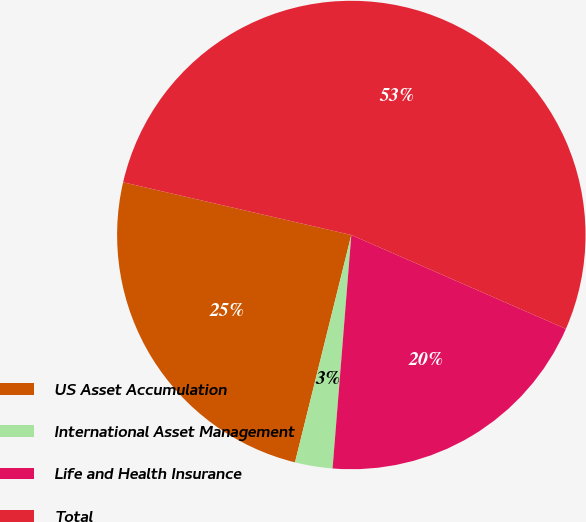Convert chart. <chart><loc_0><loc_0><loc_500><loc_500><pie_chart><fcel>US Asset Accumulation<fcel>International Asset Management<fcel>Life and Health Insurance<fcel>Total<nl><fcel>24.75%<fcel>2.59%<fcel>19.71%<fcel>52.95%<nl></chart> 